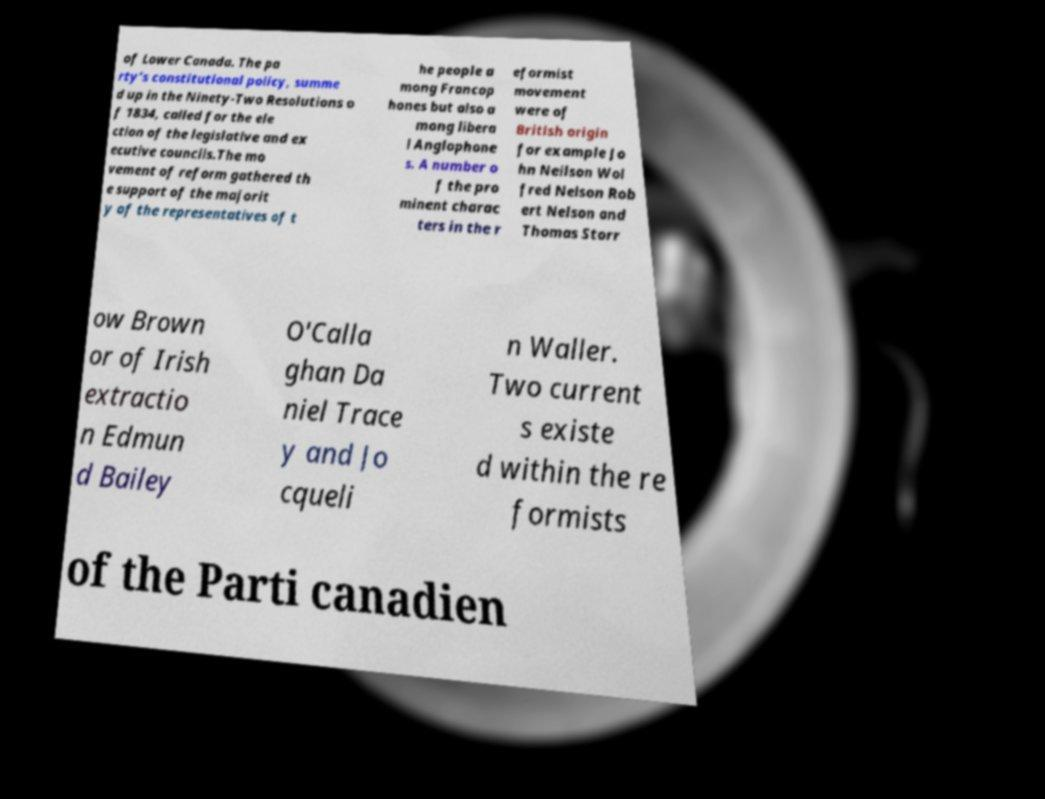Please identify and transcribe the text found in this image. of Lower Canada. The pa rty's constitutional policy, summe d up in the Ninety-Two Resolutions o f 1834, called for the ele ction of the legislative and ex ecutive councils.The mo vement of reform gathered th e support of the majorit y of the representatives of t he people a mong Francop hones but also a mong libera l Anglophone s. A number o f the pro minent charac ters in the r eformist movement were of British origin for example Jo hn Neilson Wol fred Nelson Rob ert Nelson and Thomas Storr ow Brown or of Irish extractio n Edmun d Bailey O'Calla ghan Da niel Trace y and Jo cqueli n Waller. Two current s existe d within the re formists of the Parti canadien 